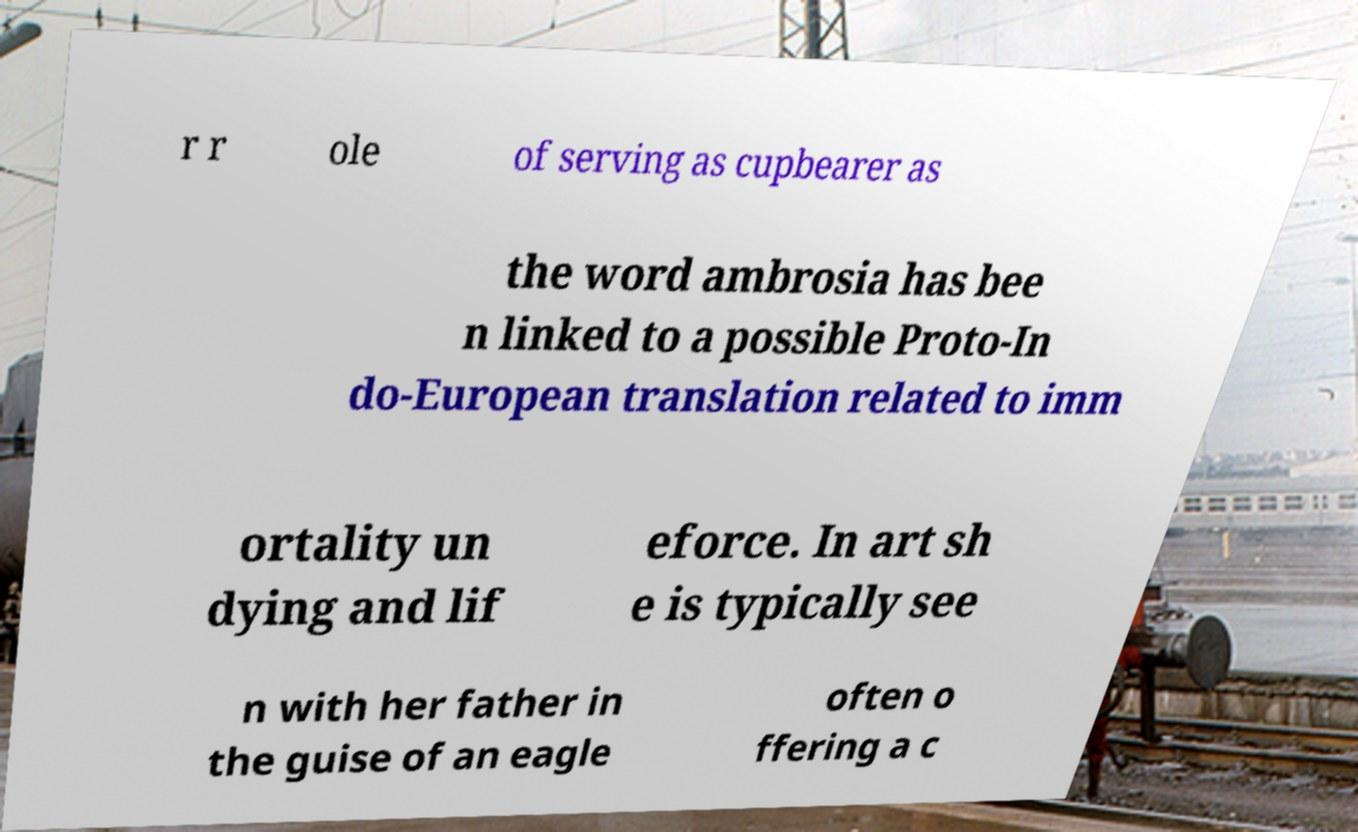What messages or text are displayed in this image? I need them in a readable, typed format. r r ole of serving as cupbearer as the word ambrosia has bee n linked to a possible Proto-In do-European translation related to imm ortality un dying and lif eforce. In art sh e is typically see n with her father in the guise of an eagle often o ffering a c 